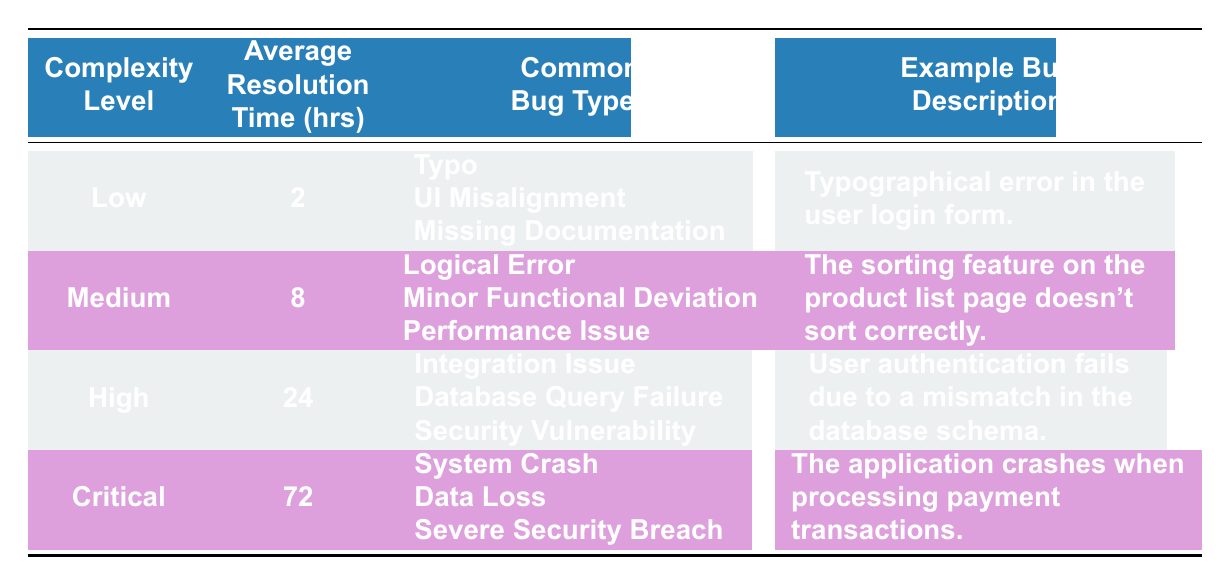What is the average resolution time for low complexity bugs? The table shows that the average resolution time for low complexity bugs is listed under the "Average Resolution Time (hrs)" column for the "Low" complexity level, which is 2 hours.
Answer: 2 hours Which bug type is listed under medium complexity issues? According to the table, one of the common bug types listed under medium complexity is "Logical Error."
Answer: Logical Error Is the average resolution time for high complexity bugs greater than 20 hours? The average resolution time for high complexity bugs is shown as 24 hours in the table, which is indeed greater than 20 hours.
Answer: Yes What is the difference in average resolution time between critical and low complexity bugs? By comparing the table, the average resolution time is 72 hours for critical complexity and 2 hours for low complexity. The difference is calculated as 72 - 2 = 70 hours.
Answer: 70 hours Are there more common bug types for high complexity than for medium complexity issues? The table shows that high complexity has three common bug types (Integration Issue, Database Query Failure, Security Vulnerability) while medium complexity also has three common bug types (Logical Error, Minor Functional Deviation, Performance Issue). Therefore, the number of common bug types is equal.
Answer: No What is the total average resolution time of all complexity levels combined? To find the total average resolution time, we sum the values: 2 (low) + 8 (medium) + 24 (high) + 72 (critical) = 106 hours, and then divide by the number of complexity levels, which is 4. The average is 106 / 4 = 26.5 hours.
Answer: 26.5 hours Which complexity level has the longest average resolution time? The table indicates that the complexity level with the longest average resolution time is "Critical," with an average of 72 hours.
Answer: Critical What example bug description is given for medium complexity issues? The example bug description listed under medium complexity in the table is "The sorting feature on the product list page doesn't sort correctly."
Answer: The sorting feature on the product list page doesn't sort correctly 